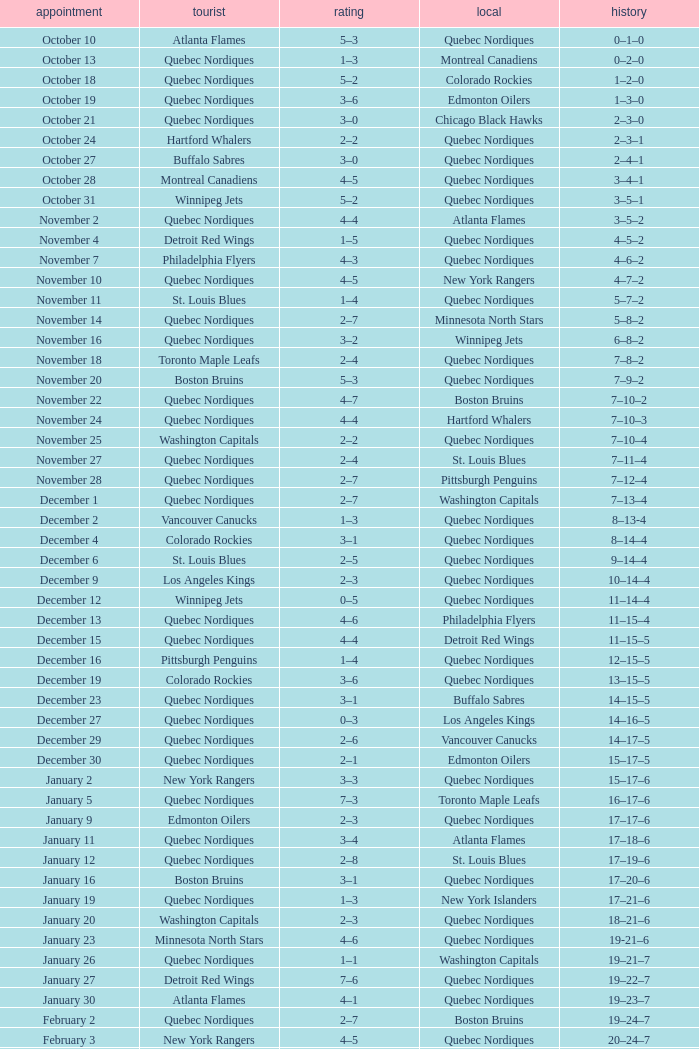Which Record has a Score of 2–4, and a Home of quebec nordiques? 7–8–2. 